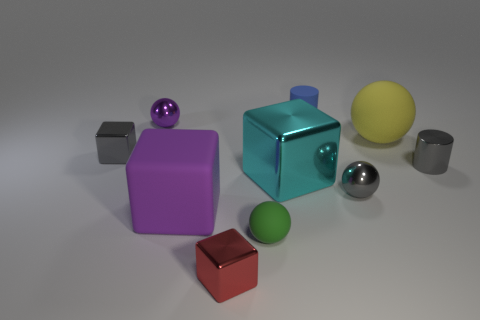Subtract all cyan shiny cubes. How many cubes are left? 3 Subtract 2 cylinders. How many cylinders are left? 0 Subtract all yellow balls. Subtract all yellow blocks. How many balls are left? 3 Subtract all purple cubes. How many blue cylinders are left? 1 Subtract all red objects. Subtract all big blocks. How many objects are left? 7 Add 2 small red metallic blocks. How many small red metallic blocks are left? 3 Add 8 big metallic things. How many big metallic things exist? 9 Subtract all green balls. How many balls are left? 3 Subtract 1 blue cylinders. How many objects are left? 9 Subtract all cylinders. How many objects are left? 8 